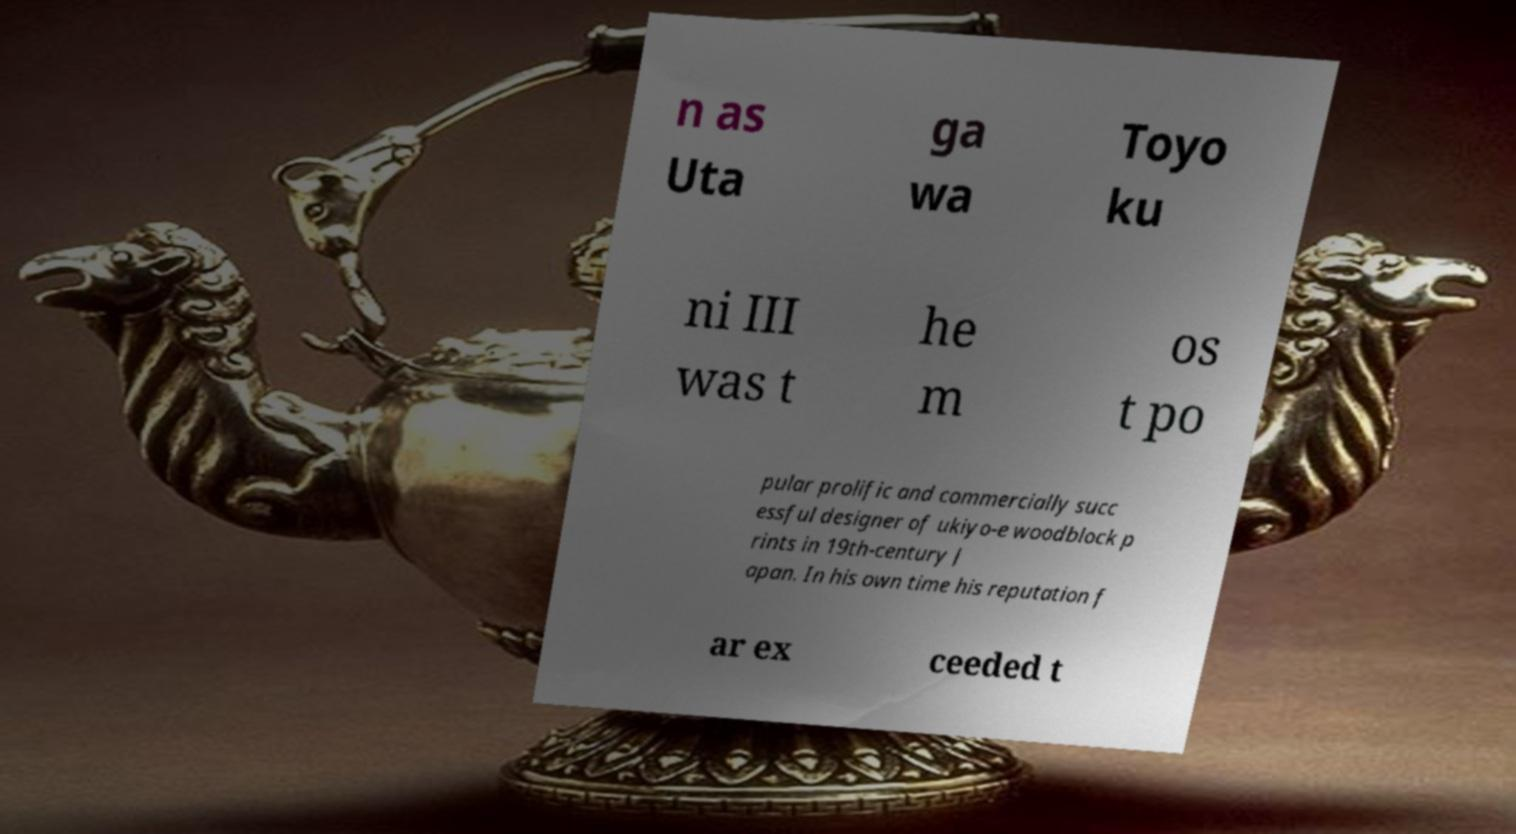There's text embedded in this image that I need extracted. Can you transcribe it verbatim? n as Uta ga wa Toyo ku ni III was t he m os t po pular prolific and commercially succ essful designer of ukiyo-e woodblock p rints in 19th-century J apan. In his own time his reputation f ar ex ceeded t 